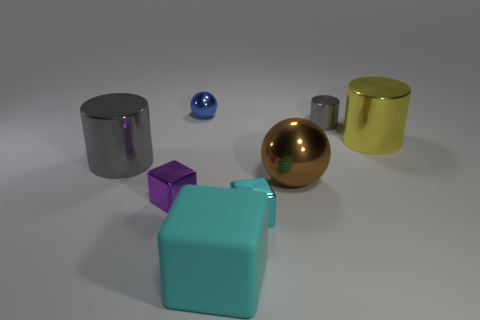Can you describe the colors and materials of the objects in the image? Certainly! The image showcases several objects with varying colors and materials. There's a sphere with a highly reflective gold finish, a small blue sphere with a glossy texture, and two cylinders; one is silver and metallic, while the other seems to have a matte yellow finish. Furthermore, there's a teal cube with a slight sheen that suggests it's made of plastic or coated metal. 